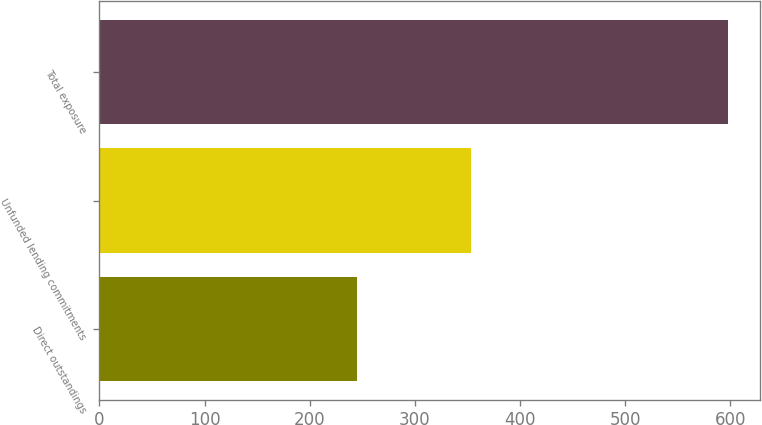Convert chart. <chart><loc_0><loc_0><loc_500><loc_500><bar_chart><fcel>Direct outstandings<fcel>Unfunded lending commitments<fcel>Total exposure<nl><fcel>245<fcel>353<fcel>598<nl></chart> 